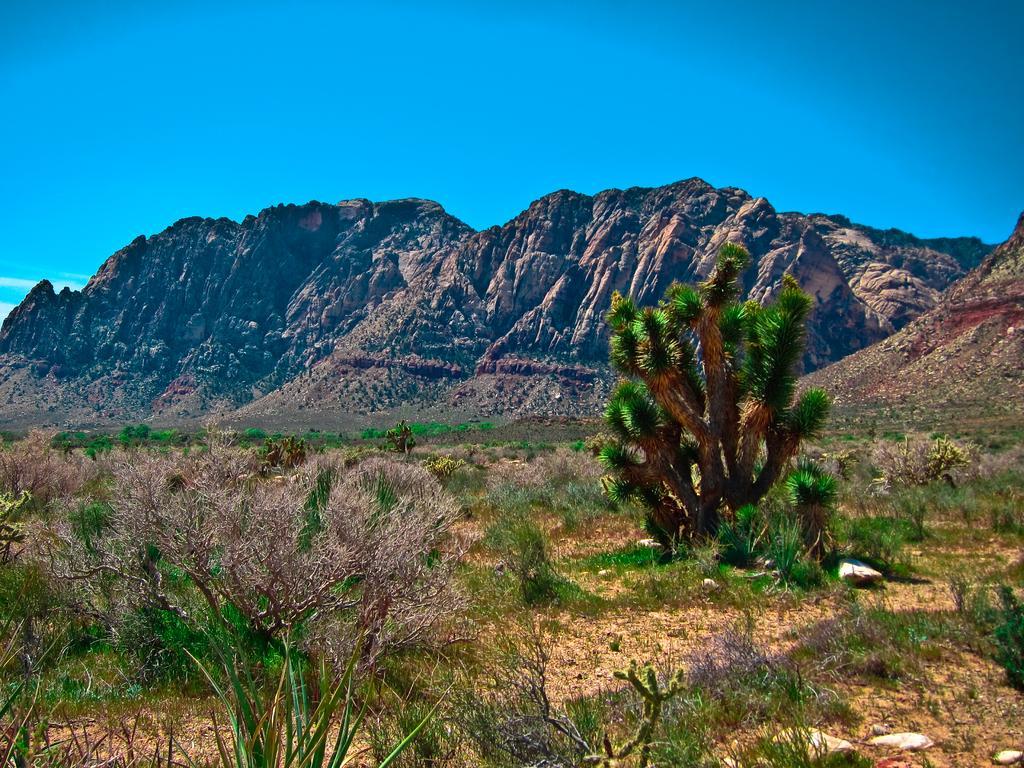Can you describe this image briefly? In this picture there is greenery at the bottom side of the image and there are mountains at the center of the image. 